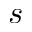<formula> <loc_0><loc_0><loc_500><loc_500>s</formula> 